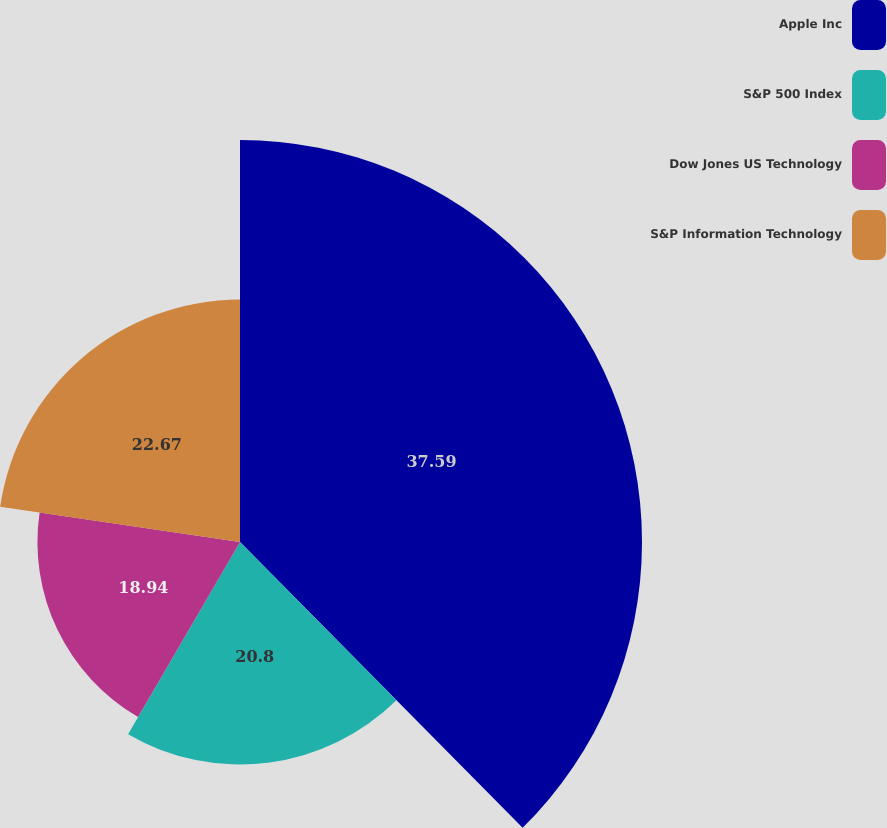Convert chart to OTSL. <chart><loc_0><loc_0><loc_500><loc_500><pie_chart><fcel>Apple Inc<fcel>S&P 500 Index<fcel>Dow Jones US Technology<fcel>S&P Information Technology<nl><fcel>37.59%<fcel>20.8%<fcel>18.94%<fcel>22.67%<nl></chart> 